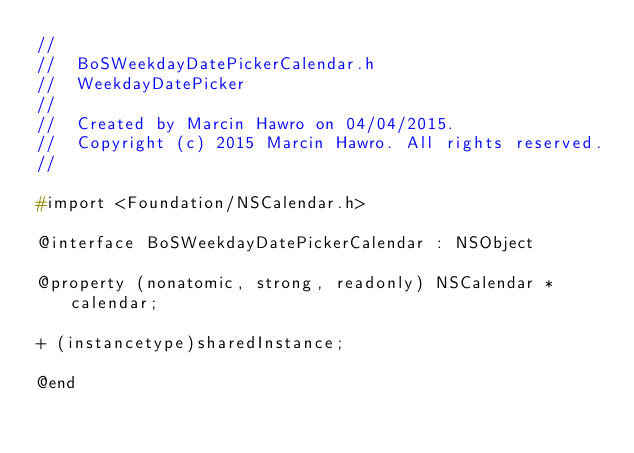Convert code to text. <code><loc_0><loc_0><loc_500><loc_500><_C_>//
//  BoSWeekdayDatePickerCalendar.h
//  WeekdayDatePicker
//
//  Created by Marcin Hawro on 04/04/2015.
//  Copyright (c) 2015 Marcin Hawro. All rights reserved.
//

#import <Foundation/NSCalendar.h>

@interface BoSWeekdayDatePickerCalendar : NSObject

@property (nonatomic, strong, readonly) NSCalendar *calendar;

+ (instancetype)sharedInstance;

@end
</code> 